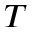<formula> <loc_0><loc_0><loc_500><loc_500>T</formula> 